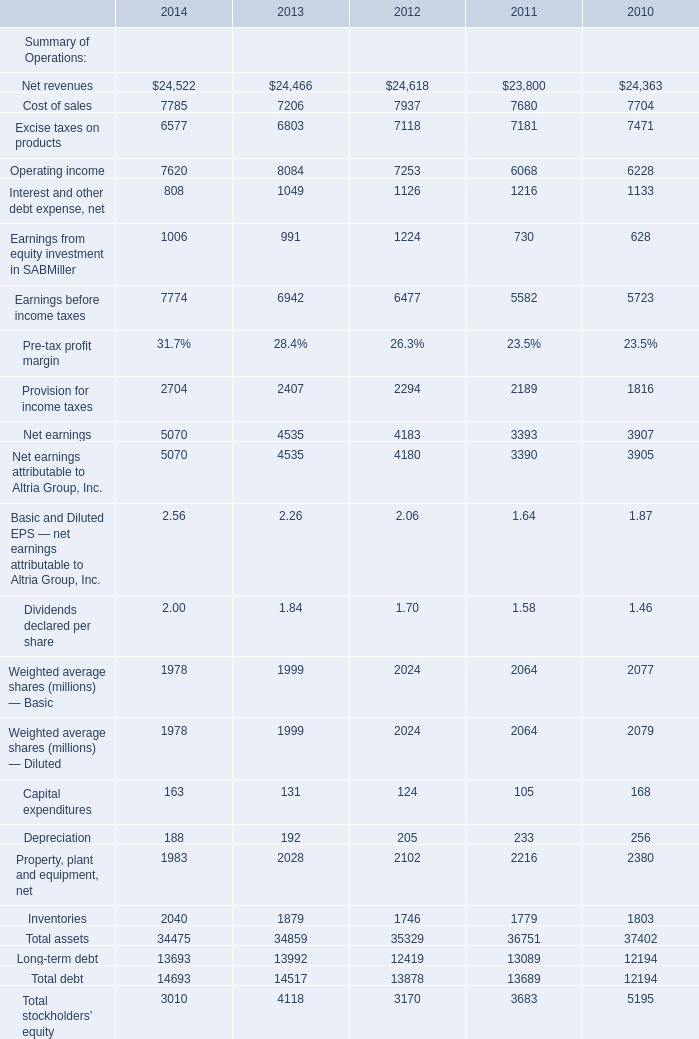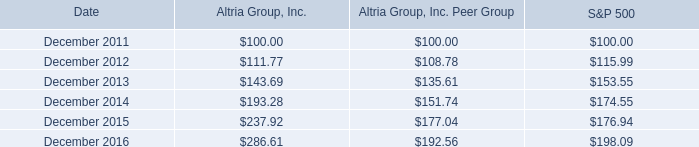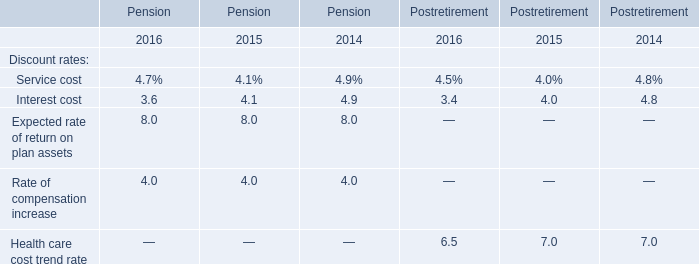what is the roi of an investment in s&p500 from december 2011 to december 2013? 
Computations: ((153.55 - 100) / 100)
Answer: 0.5355. What will Net earnings reach in 2015 if it continues to grow at its current rate? 
Computations: (5070 * (1 + ((5070 - 4535) / 4535)))
Answer: 5668.11466. 